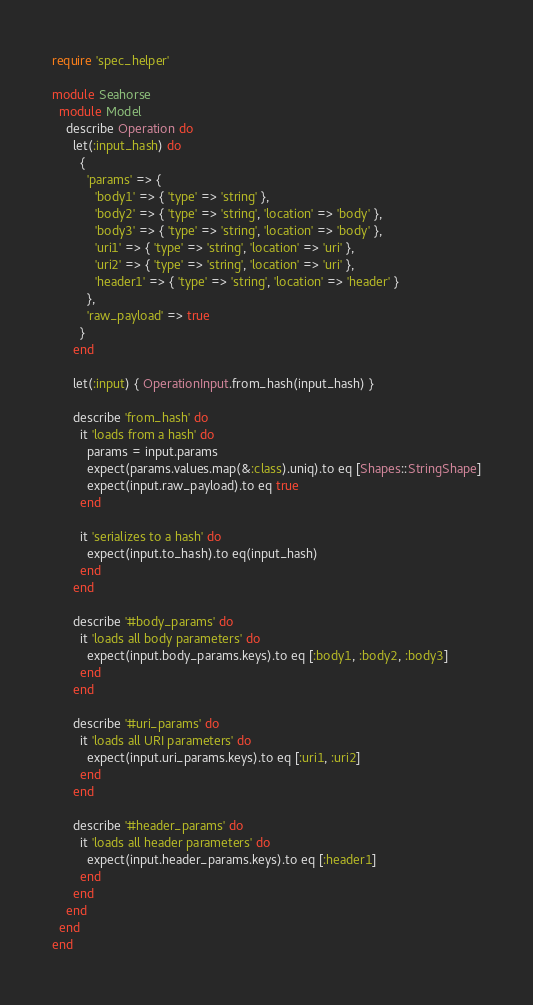Convert code to text. <code><loc_0><loc_0><loc_500><loc_500><_Ruby_>require 'spec_helper'

module Seahorse
  module Model
    describe Operation do
      let(:input_hash) do
        {
          'params' => {
            'body1' => { 'type' => 'string' },
            'body2' => { 'type' => 'string', 'location' => 'body' },
            'body3' => { 'type' => 'string', 'location' => 'body' },
            'uri1' => { 'type' => 'string', 'location' => 'uri' },
            'uri2' => { 'type' => 'string', 'location' => 'uri' },
            'header1' => { 'type' => 'string', 'location' => 'header' }
          },
          'raw_payload' => true
        }
      end

      let(:input) { OperationInput.from_hash(input_hash) }

      describe 'from_hash' do
        it 'loads from a hash' do
          params = input.params
          expect(params.values.map(&:class).uniq).to eq [Shapes::StringShape]
          expect(input.raw_payload).to eq true
        end

        it 'serializes to a hash' do
          expect(input.to_hash).to eq(input_hash)
        end
      end

      describe '#body_params' do
        it 'loads all body parameters' do
          expect(input.body_params.keys).to eq [:body1, :body2, :body3]
        end
      end

      describe '#uri_params' do
        it 'loads all URI parameters' do
          expect(input.uri_params.keys).to eq [:uri1, :uri2]
        end
      end

      describe '#header_params' do
        it 'loads all header parameters' do
          expect(input.header_params.keys).to eq [:header1]
        end
      end
    end
  end
end
</code> 